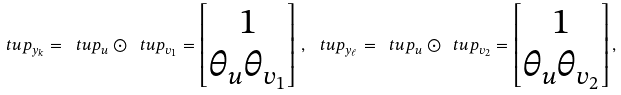<formula> <loc_0><loc_0><loc_500><loc_500>\ t u p _ { y _ { k } } = \ t u p _ { u } \odot \ t u p _ { v _ { 1 } } = \begin{bmatrix} 1 \\ \theta _ { u } \theta _ { v _ { 1 } } \end{bmatrix} \, , \, \ t u p _ { y _ { \ell } } = \ t u p _ { u } \odot \ t u p _ { v _ { 2 } } = \begin{bmatrix} 1 \\ \theta _ { u } \theta _ { v _ { 2 } } \end{bmatrix} ,</formula> 